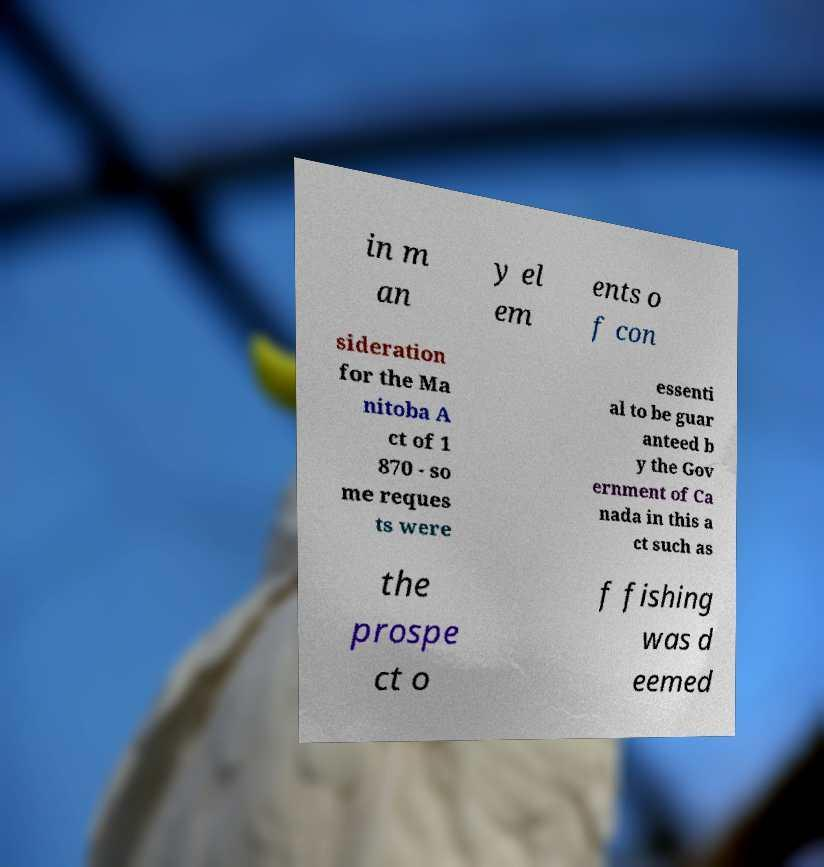Could you assist in decoding the text presented in this image and type it out clearly? in m an y el em ents o f con sideration for the Ma nitoba A ct of 1 870 - so me reques ts were essenti al to be guar anteed b y the Gov ernment of Ca nada in this a ct such as the prospe ct o f fishing was d eemed 